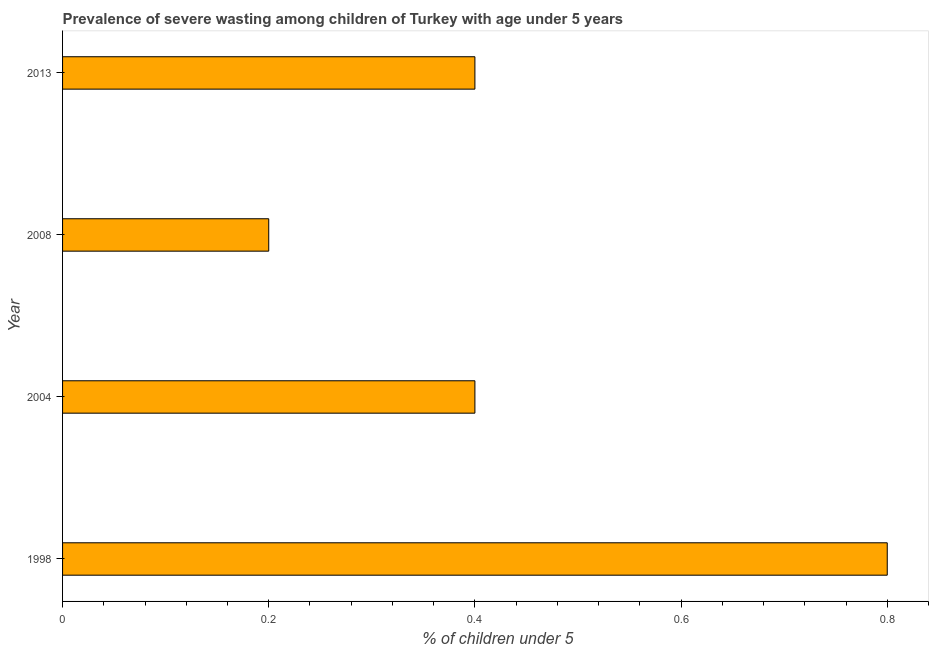Does the graph contain any zero values?
Your answer should be compact. No. What is the title of the graph?
Offer a very short reply. Prevalence of severe wasting among children of Turkey with age under 5 years. What is the label or title of the X-axis?
Ensure brevity in your answer.   % of children under 5. What is the prevalence of severe wasting in 1998?
Provide a short and direct response. 0.8. Across all years, what is the maximum prevalence of severe wasting?
Give a very brief answer. 0.8. Across all years, what is the minimum prevalence of severe wasting?
Offer a very short reply. 0.2. In which year was the prevalence of severe wasting maximum?
Keep it short and to the point. 1998. In which year was the prevalence of severe wasting minimum?
Give a very brief answer. 2008. What is the sum of the prevalence of severe wasting?
Your answer should be compact. 1.8. What is the difference between the prevalence of severe wasting in 2004 and 2008?
Your answer should be compact. 0.2. What is the average prevalence of severe wasting per year?
Offer a terse response. 0.45. What is the median prevalence of severe wasting?
Provide a short and direct response. 0.4. In how many years, is the prevalence of severe wasting greater than 0.64 %?
Offer a very short reply. 1. Do a majority of the years between 1998 and 2008 (inclusive) have prevalence of severe wasting greater than 0.2 %?
Your answer should be compact. Yes. What is the ratio of the prevalence of severe wasting in 2004 to that in 2013?
Ensure brevity in your answer.  1. Is the prevalence of severe wasting in 2004 less than that in 2008?
Give a very brief answer. No. Is the sum of the prevalence of severe wasting in 1998 and 2008 greater than the maximum prevalence of severe wasting across all years?
Offer a very short reply. Yes. How many years are there in the graph?
Give a very brief answer. 4. Are the values on the major ticks of X-axis written in scientific E-notation?
Make the answer very short. No. What is the  % of children under 5 in 1998?
Make the answer very short. 0.8. What is the  % of children under 5 in 2004?
Provide a succinct answer. 0.4. What is the  % of children under 5 of 2008?
Provide a short and direct response. 0.2. What is the  % of children under 5 of 2013?
Your answer should be compact. 0.4. What is the difference between the  % of children under 5 in 1998 and 2004?
Keep it short and to the point. 0.4. What is the difference between the  % of children under 5 in 1998 and 2008?
Keep it short and to the point. 0.6. What is the difference between the  % of children under 5 in 1998 and 2013?
Your answer should be very brief. 0.4. What is the difference between the  % of children under 5 in 2004 and 2013?
Your answer should be compact. 0. What is the difference between the  % of children under 5 in 2008 and 2013?
Offer a very short reply. -0.2. What is the ratio of the  % of children under 5 in 1998 to that in 2004?
Offer a terse response. 2. What is the ratio of the  % of children under 5 in 2004 to that in 2008?
Make the answer very short. 2. What is the ratio of the  % of children under 5 in 2004 to that in 2013?
Offer a terse response. 1. What is the ratio of the  % of children under 5 in 2008 to that in 2013?
Offer a very short reply. 0.5. 